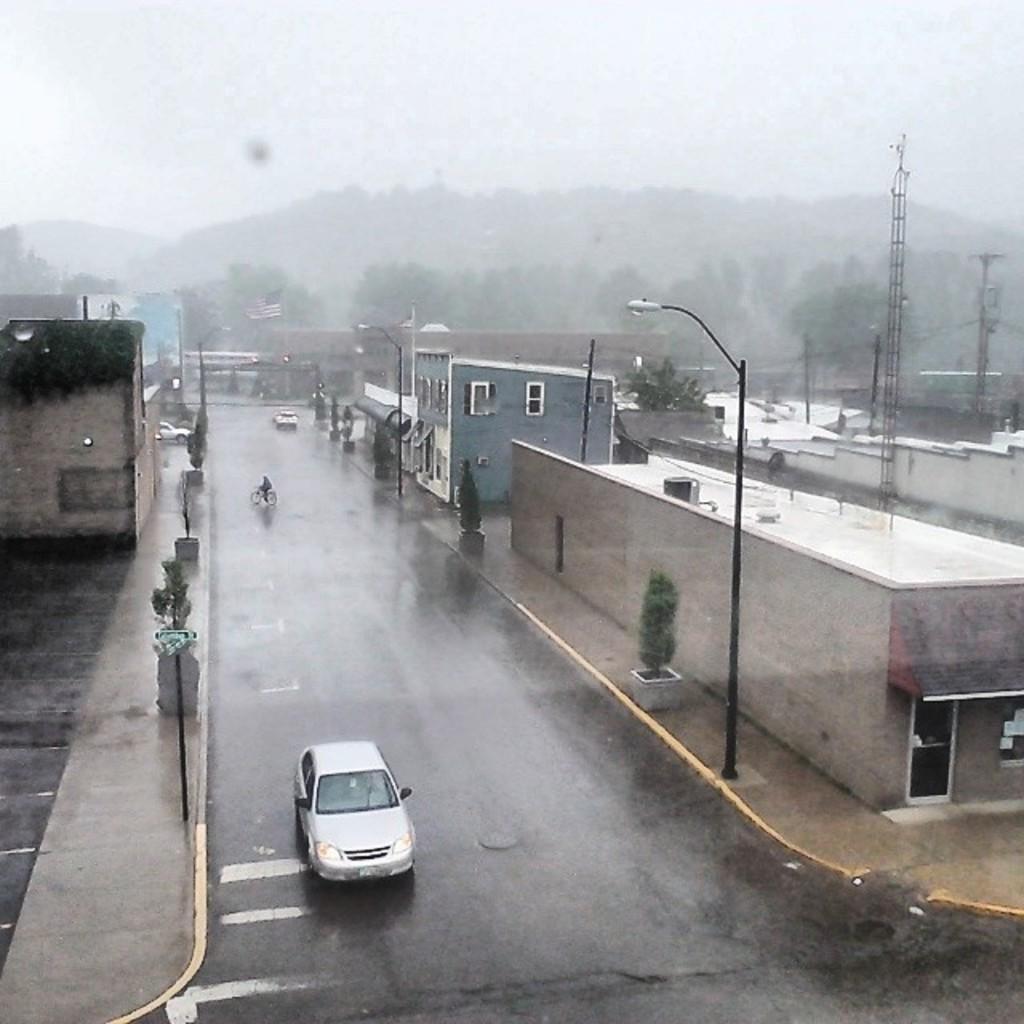Please provide a concise description of this image. In this image I can see two cars on the road and one person is riding a bicycle. On both sides of the road there are buildings, light poles and trees. In the background there is a flag and trees. At the top of the image I can see the sky. 